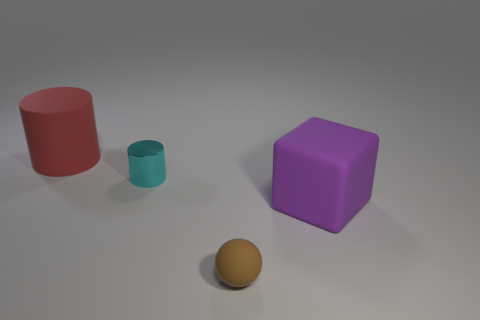Are there any cylinders made of the same material as the sphere?
Give a very brief answer. Yes. Are there more brown balls that are left of the big purple rubber cube than small matte spheres in front of the sphere?
Make the answer very short. Yes. Do the matte cube and the brown rubber sphere have the same size?
Your response must be concise. No. What is the color of the big rubber object that is on the left side of the sphere to the right of the large red rubber object?
Provide a short and direct response. Red. What is the color of the tiny ball?
Provide a succinct answer. Brown. How many things are either things on the left side of the large rubber block or big yellow shiny spheres?
Your response must be concise. 3. There is a red matte cylinder; are there any tiny brown matte objects in front of it?
Offer a very short reply. Yes. Are the tiny thing in front of the purple cube and the cube made of the same material?
Your answer should be compact. Yes. There is a big thing that is behind the big object in front of the big red thing; are there any big purple matte things in front of it?
Your answer should be very brief. Yes. How many cylinders are either big rubber things or small brown things?
Keep it short and to the point. 1. 